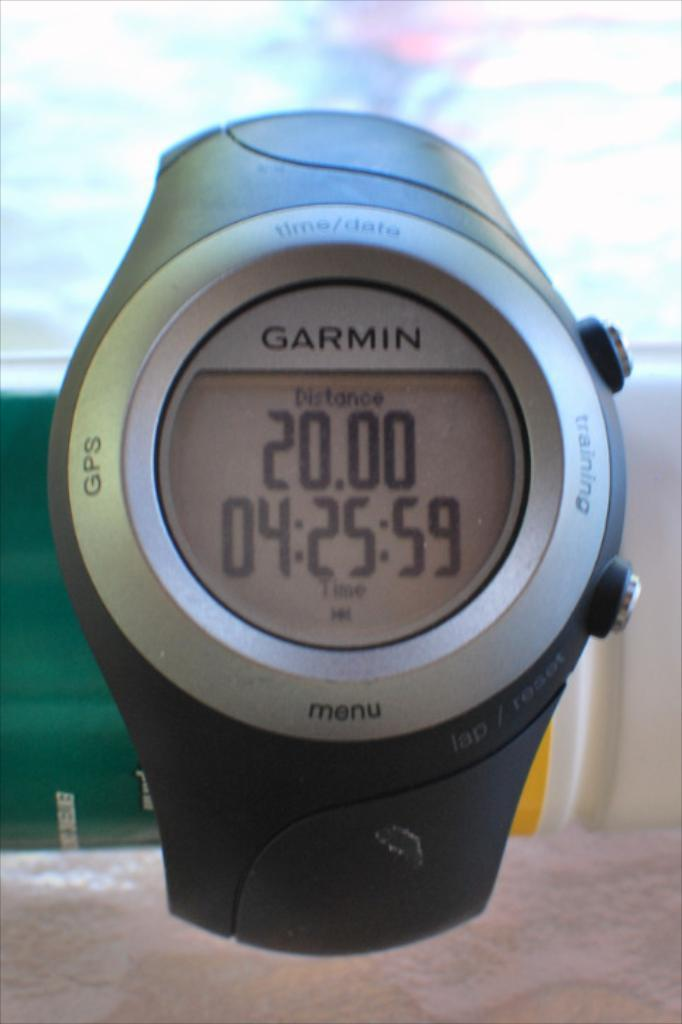<image>
Offer a succinct explanation of the picture presented. A Garmin brand watch with 4 hours, 25 minutes and 59 seconds on the clock. 